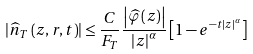<formula> <loc_0><loc_0><loc_500><loc_500>\left | \widehat { n } _ { T } \left ( z , r , t \right ) \right | \leq \frac { C } { F _ { T } } \frac { \left | \widehat { \varphi } \left ( z \right ) \right | } { \left | z \right | ^ { \alpha } } \left [ 1 - e ^ { - t \left | z \right | ^ { \alpha } } \right ]</formula> 